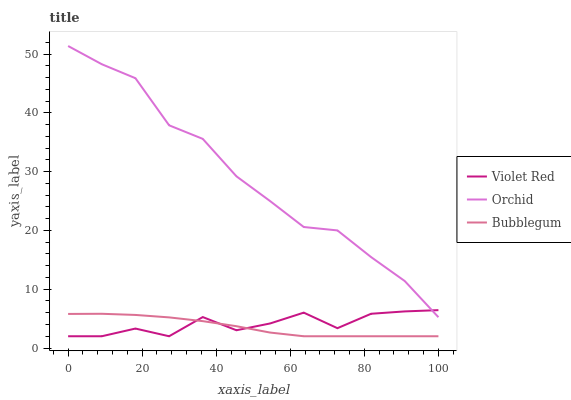Does Bubblegum have the minimum area under the curve?
Answer yes or no. Yes. Does Orchid have the maximum area under the curve?
Answer yes or no. Yes. Does Orchid have the minimum area under the curve?
Answer yes or no. No. Does Bubblegum have the maximum area under the curve?
Answer yes or no. No. Is Bubblegum the smoothest?
Answer yes or no. Yes. Is Violet Red the roughest?
Answer yes or no. Yes. Is Orchid the smoothest?
Answer yes or no. No. Is Orchid the roughest?
Answer yes or no. No. Does Violet Red have the lowest value?
Answer yes or no. Yes. Does Orchid have the lowest value?
Answer yes or no. No. Does Orchid have the highest value?
Answer yes or no. Yes. Does Bubblegum have the highest value?
Answer yes or no. No. Is Bubblegum less than Orchid?
Answer yes or no. Yes. Is Orchid greater than Bubblegum?
Answer yes or no. Yes. Does Orchid intersect Violet Red?
Answer yes or no. Yes. Is Orchid less than Violet Red?
Answer yes or no. No. Is Orchid greater than Violet Red?
Answer yes or no. No. Does Bubblegum intersect Orchid?
Answer yes or no. No. 